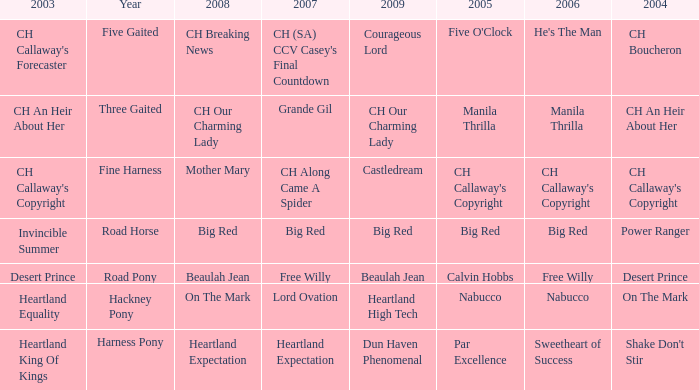What is the 2008 for 2009 heartland high tech? On The Mark. 